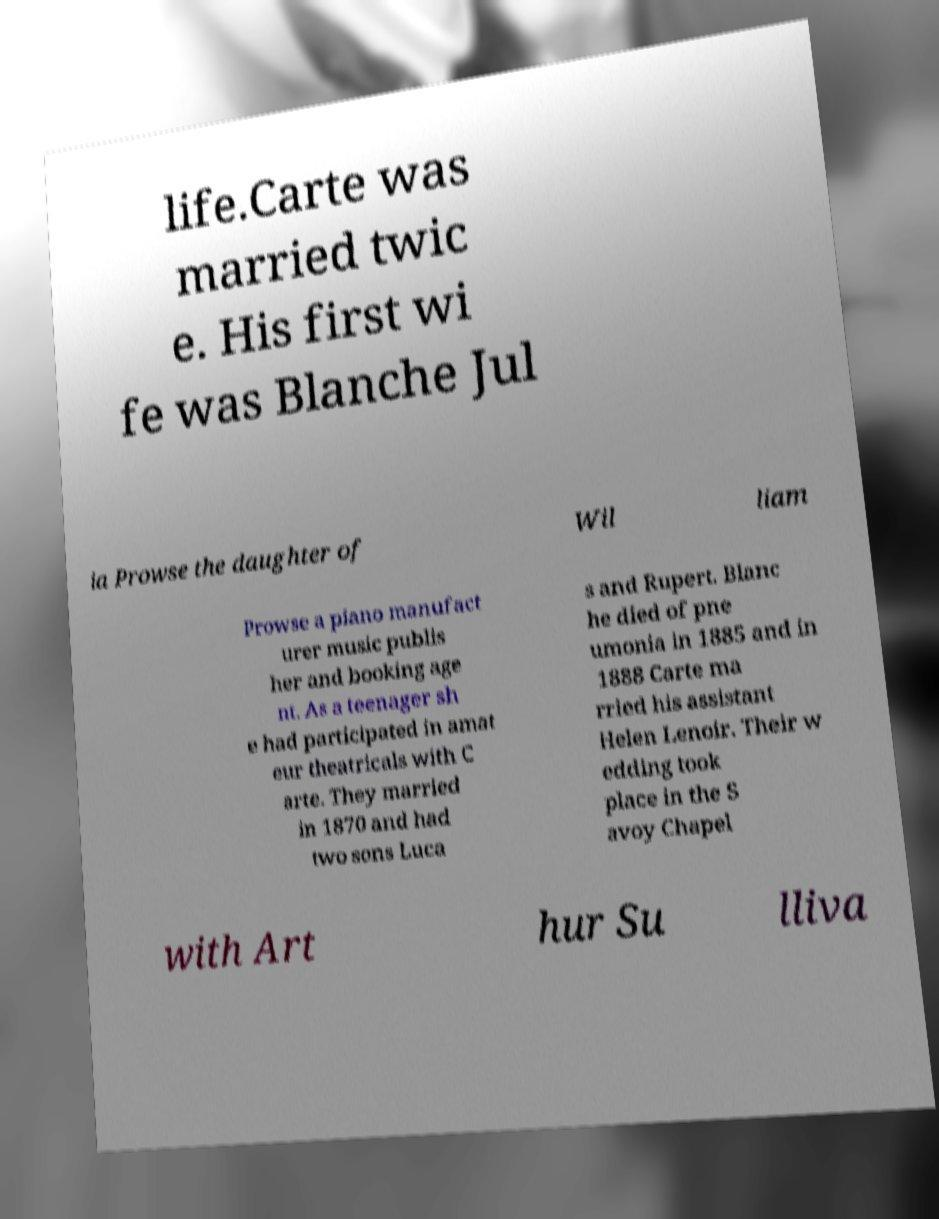Could you assist in decoding the text presented in this image and type it out clearly? life.Carte was married twic e. His first wi fe was Blanche Jul ia Prowse the daughter of Wil liam Prowse a piano manufact urer music publis her and booking age nt. As a teenager sh e had participated in amat eur theatricals with C arte. They married in 1870 and had two sons Luca s and Rupert. Blanc he died of pne umonia in 1885 and in 1888 Carte ma rried his assistant Helen Lenoir. Their w edding took place in the S avoy Chapel with Art hur Su lliva 